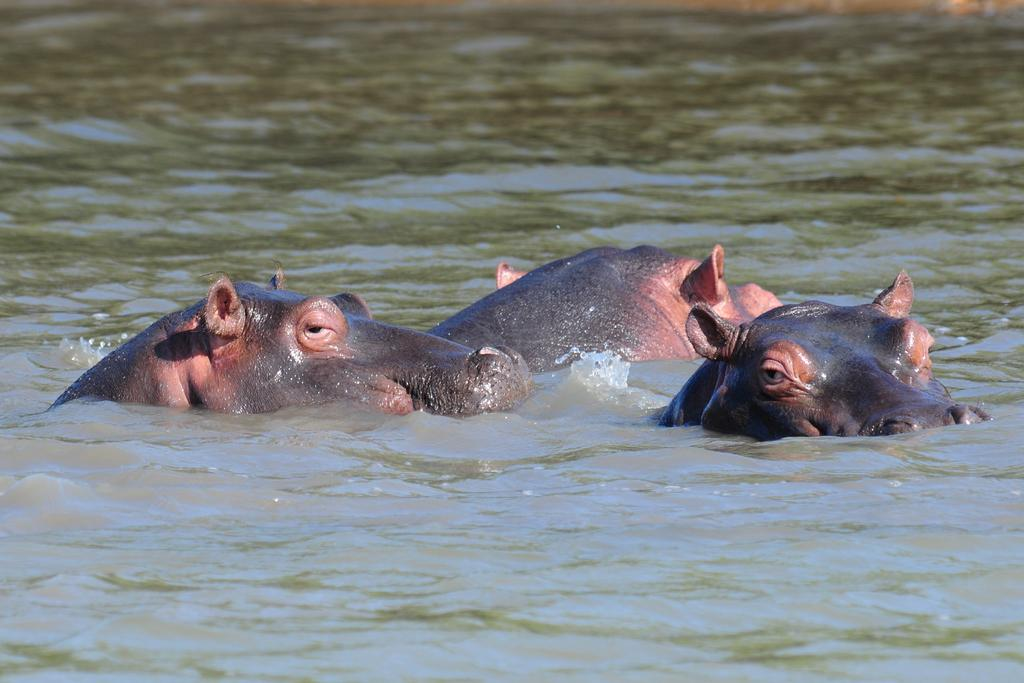What animals are present in the image? There are hippos in the image. Where are the hippos located? The hippos are in a water body. How many babies are being fed with the pump in the image? There are no babies or pumps present in the image; it features hippos in a water body. 